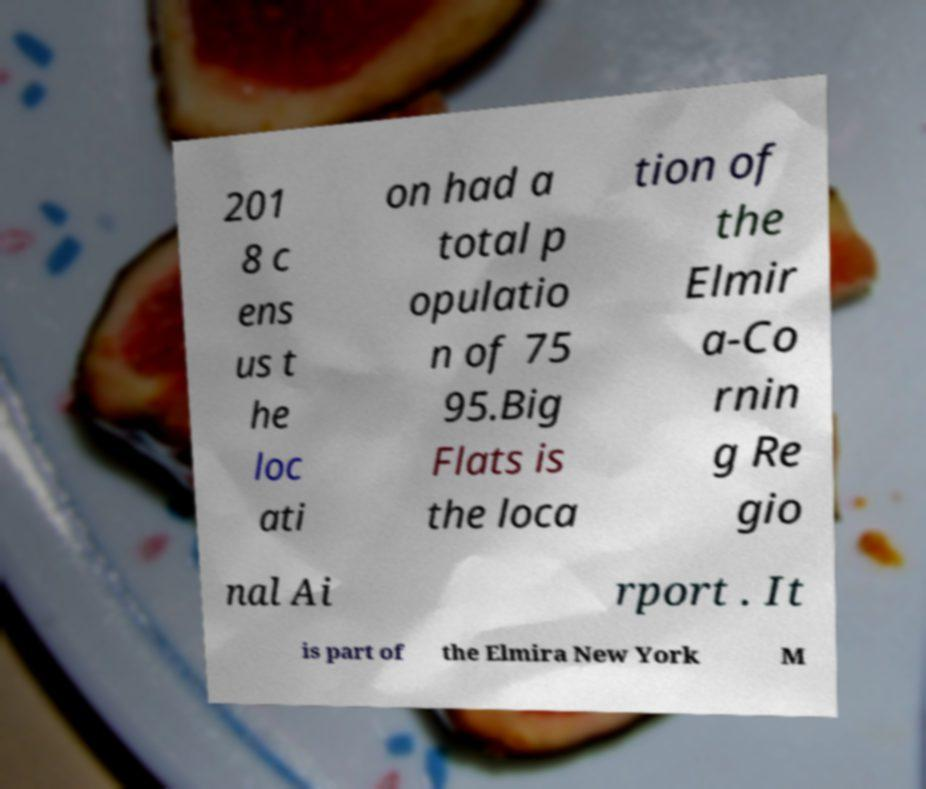There's text embedded in this image that I need extracted. Can you transcribe it verbatim? 201 8 c ens us t he loc ati on had a total p opulatio n of 75 95.Big Flats is the loca tion of the Elmir a-Co rnin g Re gio nal Ai rport . It is part of the Elmira New York M 